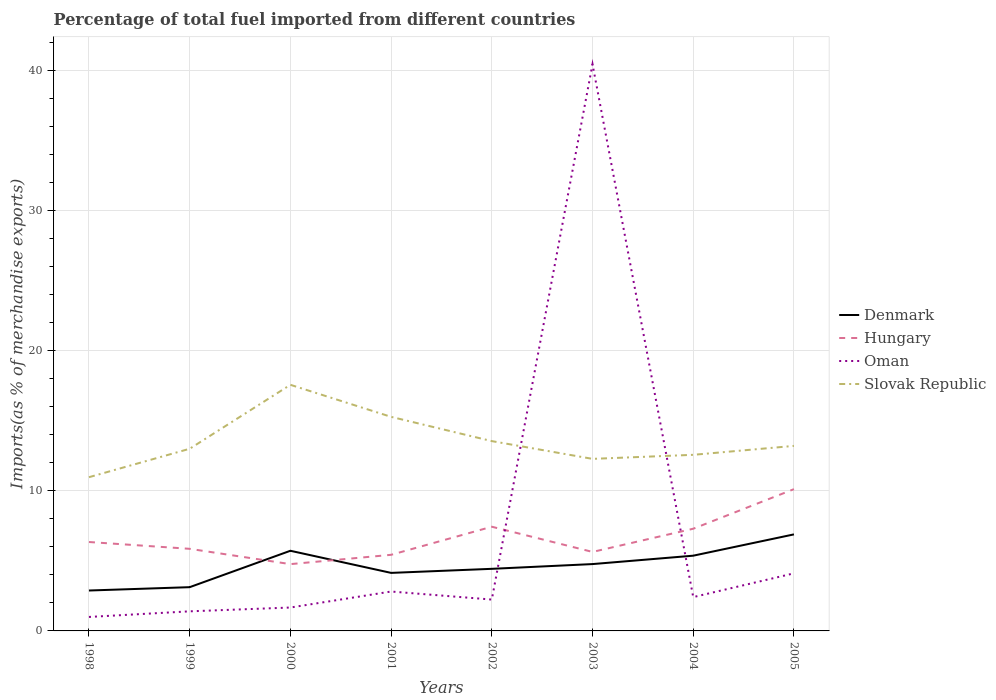Across all years, what is the maximum percentage of imports to different countries in Slovak Republic?
Provide a short and direct response. 10.98. In which year was the percentage of imports to different countries in Oman maximum?
Keep it short and to the point. 1998. What is the total percentage of imports to different countries in Slovak Republic in the graph?
Your response must be concise. 0.43. What is the difference between the highest and the second highest percentage of imports to different countries in Denmark?
Your answer should be very brief. 4.01. What is the difference between the highest and the lowest percentage of imports to different countries in Oman?
Provide a succinct answer. 1. What is the difference between two consecutive major ticks on the Y-axis?
Provide a succinct answer. 10. Does the graph contain any zero values?
Provide a short and direct response. No. Does the graph contain grids?
Provide a succinct answer. Yes. How are the legend labels stacked?
Offer a very short reply. Vertical. What is the title of the graph?
Offer a very short reply. Percentage of total fuel imported from different countries. Does "Montenegro" appear as one of the legend labels in the graph?
Keep it short and to the point. No. What is the label or title of the X-axis?
Your answer should be compact. Years. What is the label or title of the Y-axis?
Offer a very short reply. Imports(as % of merchandise exports). What is the Imports(as % of merchandise exports) of Denmark in 1998?
Make the answer very short. 2.89. What is the Imports(as % of merchandise exports) in Hungary in 1998?
Keep it short and to the point. 6.35. What is the Imports(as % of merchandise exports) of Oman in 1998?
Keep it short and to the point. 1. What is the Imports(as % of merchandise exports) in Slovak Republic in 1998?
Offer a terse response. 10.98. What is the Imports(as % of merchandise exports) of Denmark in 1999?
Offer a very short reply. 3.12. What is the Imports(as % of merchandise exports) of Hungary in 1999?
Make the answer very short. 5.86. What is the Imports(as % of merchandise exports) in Oman in 1999?
Keep it short and to the point. 1.4. What is the Imports(as % of merchandise exports) of Slovak Republic in 1999?
Offer a terse response. 13.01. What is the Imports(as % of merchandise exports) of Denmark in 2000?
Keep it short and to the point. 5.73. What is the Imports(as % of merchandise exports) of Hungary in 2000?
Your answer should be very brief. 4.77. What is the Imports(as % of merchandise exports) of Oman in 2000?
Ensure brevity in your answer.  1.67. What is the Imports(as % of merchandise exports) in Slovak Republic in 2000?
Keep it short and to the point. 17.58. What is the Imports(as % of merchandise exports) in Denmark in 2001?
Offer a terse response. 4.15. What is the Imports(as % of merchandise exports) in Hungary in 2001?
Offer a terse response. 5.44. What is the Imports(as % of merchandise exports) of Oman in 2001?
Your answer should be compact. 2.81. What is the Imports(as % of merchandise exports) of Slovak Republic in 2001?
Your answer should be very brief. 15.29. What is the Imports(as % of merchandise exports) of Denmark in 2002?
Your response must be concise. 4.44. What is the Imports(as % of merchandise exports) of Hungary in 2002?
Offer a very short reply. 7.44. What is the Imports(as % of merchandise exports) in Oman in 2002?
Your response must be concise. 2.24. What is the Imports(as % of merchandise exports) of Slovak Republic in 2002?
Provide a short and direct response. 13.56. What is the Imports(as % of merchandise exports) of Denmark in 2003?
Offer a terse response. 4.77. What is the Imports(as % of merchandise exports) in Hungary in 2003?
Your answer should be compact. 5.64. What is the Imports(as % of merchandise exports) in Oman in 2003?
Provide a succinct answer. 40.48. What is the Imports(as % of merchandise exports) in Slovak Republic in 2003?
Your response must be concise. 12.29. What is the Imports(as % of merchandise exports) in Denmark in 2004?
Make the answer very short. 5.37. What is the Imports(as % of merchandise exports) of Hungary in 2004?
Offer a terse response. 7.3. What is the Imports(as % of merchandise exports) in Oman in 2004?
Keep it short and to the point. 2.42. What is the Imports(as % of merchandise exports) in Slovak Republic in 2004?
Keep it short and to the point. 12.58. What is the Imports(as % of merchandise exports) in Denmark in 2005?
Offer a very short reply. 6.9. What is the Imports(as % of merchandise exports) of Hungary in 2005?
Provide a succinct answer. 10.13. What is the Imports(as % of merchandise exports) in Oman in 2005?
Your response must be concise. 4.11. What is the Imports(as % of merchandise exports) of Slovak Republic in 2005?
Your answer should be compact. 13.22. Across all years, what is the maximum Imports(as % of merchandise exports) in Denmark?
Ensure brevity in your answer.  6.9. Across all years, what is the maximum Imports(as % of merchandise exports) of Hungary?
Your answer should be very brief. 10.13. Across all years, what is the maximum Imports(as % of merchandise exports) of Oman?
Provide a succinct answer. 40.48. Across all years, what is the maximum Imports(as % of merchandise exports) of Slovak Republic?
Give a very brief answer. 17.58. Across all years, what is the minimum Imports(as % of merchandise exports) in Denmark?
Provide a succinct answer. 2.89. Across all years, what is the minimum Imports(as % of merchandise exports) in Hungary?
Ensure brevity in your answer.  4.77. Across all years, what is the minimum Imports(as % of merchandise exports) in Oman?
Keep it short and to the point. 1. Across all years, what is the minimum Imports(as % of merchandise exports) in Slovak Republic?
Give a very brief answer. 10.98. What is the total Imports(as % of merchandise exports) of Denmark in the graph?
Make the answer very short. 37.36. What is the total Imports(as % of merchandise exports) in Hungary in the graph?
Provide a short and direct response. 52.93. What is the total Imports(as % of merchandise exports) in Oman in the graph?
Your response must be concise. 56.13. What is the total Imports(as % of merchandise exports) in Slovak Republic in the graph?
Provide a succinct answer. 108.5. What is the difference between the Imports(as % of merchandise exports) of Denmark in 1998 and that in 1999?
Offer a very short reply. -0.24. What is the difference between the Imports(as % of merchandise exports) of Hungary in 1998 and that in 1999?
Give a very brief answer. 0.49. What is the difference between the Imports(as % of merchandise exports) of Oman in 1998 and that in 1999?
Your answer should be compact. -0.4. What is the difference between the Imports(as % of merchandise exports) of Slovak Republic in 1998 and that in 1999?
Make the answer very short. -2.03. What is the difference between the Imports(as % of merchandise exports) of Denmark in 1998 and that in 2000?
Your response must be concise. -2.84. What is the difference between the Imports(as % of merchandise exports) of Hungary in 1998 and that in 2000?
Ensure brevity in your answer.  1.58. What is the difference between the Imports(as % of merchandise exports) in Oman in 1998 and that in 2000?
Offer a very short reply. -0.67. What is the difference between the Imports(as % of merchandise exports) in Slovak Republic in 1998 and that in 2000?
Ensure brevity in your answer.  -6.6. What is the difference between the Imports(as % of merchandise exports) in Denmark in 1998 and that in 2001?
Ensure brevity in your answer.  -1.26. What is the difference between the Imports(as % of merchandise exports) in Hungary in 1998 and that in 2001?
Provide a short and direct response. 0.91. What is the difference between the Imports(as % of merchandise exports) in Oman in 1998 and that in 2001?
Make the answer very short. -1.82. What is the difference between the Imports(as % of merchandise exports) of Slovak Republic in 1998 and that in 2001?
Provide a succinct answer. -4.31. What is the difference between the Imports(as % of merchandise exports) of Denmark in 1998 and that in 2002?
Give a very brief answer. -1.55. What is the difference between the Imports(as % of merchandise exports) in Hungary in 1998 and that in 2002?
Ensure brevity in your answer.  -1.09. What is the difference between the Imports(as % of merchandise exports) of Oman in 1998 and that in 2002?
Your response must be concise. -1.24. What is the difference between the Imports(as % of merchandise exports) in Slovak Republic in 1998 and that in 2002?
Provide a short and direct response. -2.58. What is the difference between the Imports(as % of merchandise exports) of Denmark in 1998 and that in 2003?
Your answer should be compact. -1.89. What is the difference between the Imports(as % of merchandise exports) in Hungary in 1998 and that in 2003?
Give a very brief answer. 0.71. What is the difference between the Imports(as % of merchandise exports) of Oman in 1998 and that in 2003?
Ensure brevity in your answer.  -39.48. What is the difference between the Imports(as % of merchandise exports) of Slovak Republic in 1998 and that in 2003?
Your answer should be compact. -1.31. What is the difference between the Imports(as % of merchandise exports) of Denmark in 1998 and that in 2004?
Offer a very short reply. -2.49. What is the difference between the Imports(as % of merchandise exports) of Hungary in 1998 and that in 2004?
Make the answer very short. -0.95. What is the difference between the Imports(as % of merchandise exports) in Oman in 1998 and that in 2004?
Give a very brief answer. -1.42. What is the difference between the Imports(as % of merchandise exports) in Slovak Republic in 1998 and that in 2004?
Your answer should be compact. -1.6. What is the difference between the Imports(as % of merchandise exports) in Denmark in 1998 and that in 2005?
Provide a short and direct response. -4.01. What is the difference between the Imports(as % of merchandise exports) of Hungary in 1998 and that in 2005?
Your answer should be compact. -3.78. What is the difference between the Imports(as % of merchandise exports) of Oman in 1998 and that in 2005?
Give a very brief answer. -3.12. What is the difference between the Imports(as % of merchandise exports) in Slovak Republic in 1998 and that in 2005?
Provide a succinct answer. -2.24. What is the difference between the Imports(as % of merchandise exports) in Denmark in 1999 and that in 2000?
Provide a succinct answer. -2.6. What is the difference between the Imports(as % of merchandise exports) in Hungary in 1999 and that in 2000?
Give a very brief answer. 1.09. What is the difference between the Imports(as % of merchandise exports) of Oman in 1999 and that in 2000?
Your response must be concise. -0.27. What is the difference between the Imports(as % of merchandise exports) in Slovak Republic in 1999 and that in 2000?
Provide a short and direct response. -4.57. What is the difference between the Imports(as % of merchandise exports) in Denmark in 1999 and that in 2001?
Give a very brief answer. -1.02. What is the difference between the Imports(as % of merchandise exports) in Hungary in 1999 and that in 2001?
Provide a succinct answer. 0.43. What is the difference between the Imports(as % of merchandise exports) of Oman in 1999 and that in 2001?
Provide a succinct answer. -1.41. What is the difference between the Imports(as % of merchandise exports) in Slovak Republic in 1999 and that in 2001?
Provide a short and direct response. -2.28. What is the difference between the Imports(as % of merchandise exports) in Denmark in 1999 and that in 2002?
Give a very brief answer. -1.31. What is the difference between the Imports(as % of merchandise exports) of Hungary in 1999 and that in 2002?
Your answer should be very brief. -1.58. What is the difference between the Imports(as % of merchandise exports) in Oman in 1999 and that in 2002?
Your response must be concise. -0.84. What is the difference between the Imports(as % of merchandise exports) in Slovak Republic in 1999 and that in 2002?
Give a very brief answer. -0.55. What is the difference between the Imports(as % of merchandise exports) in Denmark in 1999 and that in 2003?
Provide a short and direct response. -1.65. What is the difference between the Imports(as % of merchandise exports) in Hungary in 1999 and that in 2003?
Your answer should be compact. 0.22. What is the difference between the Imports(as % of merchandise exports) of Oman in 1999 and that in 2003?
Keep it short and to the point. -39.08. What is the difference between the Imports(as % of merchandise exports) in Slovak Republic in 1999 and that in 2003?
Provide a succinct answer. 0.72. What is the difference between the Imports(as % of merchandise exports) of Denmark in 1999 and that in 2004?
Your response must be concise. -2.25. What is the difference between the Imports(as % of merchandise exports) of Hungary in 1999 and that in 2004?
Provide a succinct answer. -1.44. What is the difference between the Imports(as % of merchandise exports) of Oman in 1999 and that in 2004?
Ensure brevity in your answer.  -1.02. What is the difference between the Imports(as % of merchandise exports) of Slovak Republic in 1999 and that in 2004?
Offer a very short reply. 0.43. What is the difference between the Imports(as % of merchandise exports) of Denmark in 1999 and that in 2005?
Your response must be concise. -3.77. What is the difference between the Imports(as % of merchandise exports) in Hungary in 1999 and that in 2005?
Offer a very short reply. -4.26. What is the difference between the Imports(as % of merchandise exports) in Oman in 1999 and that in 2005?
Offer a terse response. -2.71. What is the difference between the Imports(as % of merchandise exports) in Slovak Republic in 1999 and that in 2005?
Keep it short and to the point. -0.2. What is the difference between the Imports(as % of merchandise exports) in Denmark in 2000 and that in 2001?
Your answer should be very brief. 1.58. What is the difference between the Imports(as % of merchandise exports) in Hungary in 2000 and that in 2001?
Provide a succinct answer. -0.67. What is the difference between the Imports(as % of merchandise exports) of Oman in 2000 and that in 2001?
Your answer should be very brief. -1.14. What is the difference between the Imports(as % of merchandise exports) of Slovak Republic in 2000 and that in 2001?
Your answer should be very brief. 2.29. What is the difference between the Imports(as % of merchandise exports) in Denmark in 2000 and that in 2002?
Your response must be concise. 1.29. What is the difference between the Imports(as % of merchandise exports) in Hungary in 2000 and that in 2002?
Offer a terse response. -2.67. What is the difference between the Imports(as % of merchandise exports) in Oman in 2000 and that in 2002?
Your answer should be very brief. -0.57. What is the difference between the Imports(as % of merchandise exports) of Slovak Republic in 2000 and that in 2002?
Your answer should be compact. 4.02. What is the difference between the Imports(as % of merchandise exports) in Denmark in 2000 and that in 2003?
Make the answer very short. 0.95. What is the difference between the Imports(as % of merchandise exports) of Hungary in 2000 and that in 2003?
Provide a succinct answer. -0.87. What is the difference between the Imports(as % of merchandise exports) in Oman in 2000 and that in 2003?
Your answer should be very brief. -38.81. What is the difference between the Imports(as % of merchandise exports) in Slovak Republic in 2000 and that in 2003?
Provide a succinct answer. 5.29. What is the difference between the Imports(as % of merchandise exports) of Denmark in 2000 and that in 2004?
Your response must be concise. 0.35. What is the difference between the Imports(as % of merchandise exports) in Hungary in 2000 and that in 2004?
Make the answer very short. -2.53. What is the difference between the Imports(as % of merchandise exports) of Oman in 2000 and that in 2004?
Keep it short and to the point. -0.74. What is the difference between the Imports(as % of merchandise exports) in Slovak Republic in 2000 and that in 2004?
Your answer should be very brief. 5. What is the difference between the Imports(as % of merchandise exports) in Denmark in 2000 and that in 2005?
Give a very brief answer. -1.17. What is the difference between the Imports(as % of merchandise exports) in Hungary in 2000 and that in 2005?
Your response must be concise. -5.36. What is the difference between the Imports(as % of merchandise exports) in Oman in 2000 and that in 2005?
Provide a succinct answer. -2.44. What is the difference between the Imports(as % of merchandise exports) of Slovak Republic in 2000 and that in 2005?
Your answer should be very brief. 4.36. What is the difference between the Imports(as % of merchandise exports) of Denmark in 2001 and that in 2002?
Provide a short and direct response. -0.29. What is the difference between the Imports(as % of merchandise exports) in Hungary in 2001 and that in 2002?
Your answer should be compact. -2.01. What is the difference between the Imports(as % of merchandise exports) of Oman in 2001 and that in 2002?
Ensure brevity in your answer.  0.57. What is the difference between the Imports(as % of merchandise exports) in Slovak Republic in 2001 and that in 2002?
Provide a succinct answer. 1.73. What is the difference between the Imports(as % of merchandise exports) in Denmark in 2001 and that in 2003?
Provide a succinct answer. -0.63. What is the difference between the Imports(as % of merchandise exports) of Hungary in 2001 and that in 2003?
Give a very brief answer. -0.21. What is the difference between the Imports(as % of merchandise exports) of Oman in 2001 and that in 2003?
Give a very brief answer. -37.66. What is the difference between the Imports(as % of merchandise exports) of Slovak Republic in 2001 and that in 2003?
Make the answer very short. 3. What is the difference between the Imports(as % of merchandise exports) in Denmark in 2001 and that in 2004?
Offer a terse response. -1.23. What is the difference between the Imports(as % of merchandise exports) in Hungary in 2001 and that in 2004?
Offer a very short reply. -1.86. What is the difference between the Imports(as % of merchandise exports) in Oman in 2001 and that in 2004?
Your answer should be compact. 0.4. What is the difference between the Imports(as % of merchandise exports) of Slovak Republic in 2001 and that in 2004?
Ensure brevity in your answer.  2.71. What is the difference between the Imports(as % of merchandise exports) in Denmark in 2001 and that in 2005?
Provide a short and direct response. -2.75. What is the difference between the Imports(as % of merchandise exports) in Hungary in 2001 and that in 2005?
Make the answer very short. -4.69. What is the difference between the Imports(as % of merchandise exports) of Oman in 2001 and that in 2005?
Your answer should be compact. -1.3. What is the difference between the Imports(as % of merchandise exports) in Slovak Republic in 2001 and that in 2005?
Provide a succinct answer. 2.07. What is the difference between the Imports(as % of merchandise exports) in Denmark in 2002 and that in 2003?
Offer a very short reply. -0.34. What is the difference between the Imports(as % of merchandise exports) in Hungary in 2002 and that in 2003?
Provide a succinct answer. 1.8. What is the difference between the Imports(as % of merchandise exports) in Oman in 2002 and that in 2003?
Your response must be concise. -38.24. What is the difference between the Imports(as % of merchandise exports) of Slovak Republic in 2002 and that in 2003?
Your answer should be very brief. 1.27. What is the difference between the Imports(as % of merchandise exports) in Denmark in 2002 and that in 2004?
Your response must be concise. -0.94. What is the difference between the Imports(as % of merchandise exports) of Hungary in 2002 and that in 2004?
Provide a succinct answer. 0.14. What is the difference between the Imports(as % of merchandise exports) of Oman in 2002 and that in 2004?
Give a very brief answer. -0.18. What is the difference between the Imports(as % of merchandise exports) of Slovak Republic in 2002 and that in 2004?
Your response must be concise. 0.98. What is the difference between the Imports(as % of merchandise exports) in Denmark in 2002 and that in 2005?
Offer a very short reply. -2.46. What is the difference between the Imports(as % of merchandise exports) in Hungary in 2002 and that in 2005?
Make the answer very short. -2.68. What is the difference between the Imports(as % of merchandise exports) in Oman in 2002 and that in 2005?
Give a very brief answer. -1.87. What is the difference between the Imports(as % of merchandise exports) in Slovak Republic in 2002 and that in 2005?
Ensure brevity in your answer.  0.34. What is the difference between the Imports(as % of merchandise exports) in Denmark in 2003 and that in 2004?
Offer a very short reply. -0.6. What is the difference between the Imports(as % of merchandise exports) in Hungary in 2003 and that in 2004?
Provide a short and direct response. -1.66. What is the difference between the Imports(as % of merchandise exports) in Oman in 2003 and that in 2004?
Give a very brief answer. 38.06. What is the difference between the Imports(as % of merchandise exports) of Slovak Republic in 2003 and that in 2004?
Ensure brevity in your answer.  -0.29. What is the difference between the Imports(as % of merchandise exports) in Denmark in 2003 and that in 2005?
Your response must be concise. -2.12. What is the difference between the Imports(as % of merchandise exports) of Hungary in 2003 and that in 2005?
Your response must be concise. -4.48. What is the difference between the Imports(as % of merchandise exports) of Oman in 2003 and that in 2005?
Offer a terse response. 36.37. What is the difference between the Imports(as % of merchandise exports) in Slovak Republic in 2003 and that in 2005?
Give a very brief answer. -0.93. What is the difference between the Imports(as % of merchandise exports) in Denmark in 2004 and that in 2005?
Your answer should be compact. -1.52. What is the difference between the Imports(as % of merchandise exports) of Hungary in 2004 and that in 2005?
Give a very brief answer. -2.83. What is the difference between the Imports(as % of merchandise exports) of Oman in 2004 and that in 2005?
Give a very brief answer. -1.7. What is the difference between the Imports(as % of merchandise exports) in Slovak Republic in 2004 and that in 2005?
Make the answer very short. -0.64. What is the difference between the Imports(as % of merchandise exports) in Denmark in 1998 and the Imports(as % of merchandise exports) in Hungary in 1999?
Keep it short and to the point. -2.98. What is the difference between the Imports(as % of merchandise exports) of Denmark in 1998 and the Imports(as % of merchandise exports) of Oman in 1999?
Your response must be concise. 1.49. What is the difference between the Imports(as % of merchandise exports) in Denmark in 1998 and the Imports(as % of merchandise exports) in Slovak Republic in 1999?
Your response must be concise. -10.13. What is the difference between the Imports(as % of merchandise exports) of Hungary in 1998 and the Imports(as % of merchandise exports) of Oman in 1999?
Provide a short and direct response. 4.95. What is the difference between the Imports(as % of merchandise exports) in Hungary in 1998 and the Imports(as % of merchandise exports) in Slovak Republic in 1999?
Your answer should be compact. -6.66. What is the difference between the Imports(as % of merchandise exports) in Oman in 1998 and the Imports(as % of merchandise exports) in Slovak Republic in 1999?
Ensure brevity in your answer.  -12.01. What is the difference between the Imports(as % of merchandise exports) of Denmark in 1998 and the Imports(as % of merchandise exports) of Hungary in 2000?
Your answer should be compact. -1.88. What is the difference between the Imports(as % of merchandise exports) of Denmark in 1998 and the Imports(as % of merchandise exports) of Oman in 2000?
Your answer should be compact. 1.21. What is the difference between the Imports(as % of merchandise exports) in Denmark in 1998 and the Imports(as % of merchandise exports) in Slovak Republic in 2000?
Your response must be concise. -14.69. What is the difference between the Imports(as % of merchandise exports) in Hungary in 1998 and the Imports(as % of merchandise exports) in Oman in 2000?
Your response must be concise. 4.68. What is the difference between the Imports(as % of merchandise exports) in Hungary in 1998 and the Imports(as % of merchandise exports) in Slovak Republic in 2000?
Ensure brevity in your answer.  -11.23. What is the difference between the Imports(as % of merchandise exports) in Oman in 1998 and the Imports(as % of merchandise exports) in Slovak Republic in 2000?
Your response must be concise. -16.58. What is the difference between the Imports(as % of merchandise exports) in Denmark in 1998 and the Imports(as % of merchandise exports) in Hungary in 2001?
Provide a succinct answer. -2.55. What is the difference between the Imports(as % of merchandise exports) in Denmark in 1998 and the Imports(as % of merchandise exports) in Oman in 2001?
Make the answer very short. 0.07. What is the difference between the Imports(as % of merchandise exports) of Denmark in 1998 and the Imports(as % of merchandise exports) of Slovak Republic in 2001?
Your answer should be compact. -12.4. What is the difference between the Imports(as % of merchandise exports) of Hungary in 1998 and the Imports(as % of merchandise exports) of Oman in 2001?
Ensure brevity in your answer.  3.54. What is the difference between the Imports(as % of merchandise exports) in Hungary in 1998 and the Imports(as % of merchandise exports) in Slovak Republic in 2001?
Offer a very short reply. -8.94. What is the difference between the Imports(as % of merchandise exports) of Oman in 1998 and the Imports(as % of merchandise exports) of Slovak Republic in 2001?
Provide a short and direct response. -14.29. What is the difference between the Imports(as % of merchandise exports) in Denmark in 1998 and the Imports(as % of merchandise exports) in Hungary in 2002?
Your answer should be very brief. -4.56. What is the difference between the Imports(as % of merchandise exports) in Denmark in 1998 and the Imports(as % of merchandise exports) in Oman in 2002?
Give a very brief answer. 0.65. What is the difference between the Imports(as % of merchandise exports) in Denmark in 1998 and the Imports(as % of merchandise exports) in Slovak Republic in 2002?
Offer a very short reply. -10.67. What is the difference between the Imports(as % of merchandise exports) of Hungary in 1998 and the Imports(as % of merchandise exports) of Oman in 2002?
Keep it short and to the point. 4.11. What is the difference between the Imports(as % of merchandise exports) in Hungary in 1998 and the Imports(as % of merchandise exports) in Slovak Republic in 2002?
Offer a very short reply. -7.21. What is the difference between the Imports(as % of merchandise exports) of Oman in 1998 and the Imports(as % of merchandise exports) of Slovak Republic in 2002?
Keep it short and to the point. -12.56. What is the difference between the Imports(as % of merchandise exports) of Denmark in 1998 and the Imports(as % of merchandise exports) of Hungary in 2003?
Provide a succinct answer. -2.76. What is the difference between the Imports(as % of merchandise exports) of Denmark in 1998 and the Imports(as % of merchandise exports) of Oman in 2003?
Provide a succinct answer. -37.59. What is the difference between the Imports(as % of merchandise exports) in Denmark in 1998 and the Imports(as % of merchandise exports) in Slovak Republic in 2003?
Keep it short and to the point. -9.4. What is the difference between the Imports(as % of merchandise exports) of Hungary in 1998 and the Imports(as % of merchandise exports) of Oman in 2003?
Your answer should be compact. -34.13. What is the difference between the Imports(as % of merchandise exports) of Hungary in 1998 and the Imports(as % of merchandise exports) of Slovak Republic in 2003?
Offer a terse response. -5.94. What is the difference between the Imports(as % of merchandise exports) of Oman in 1998 and the Imports(as % of merchandise exports) of Slovak Republic in 2003?
Offer a very short reply. -11.29. What is the difference between the Imports(as % of merchandise exports) of Denmark in 1998 and the Imports(as % of merchandise exports) of Hungary in 2004?
Provide a short and direct response. -4.41. What is the difference between the Imports(as % of merchandise exports) of Denmark in 1998 and the Imports(as % of merchandise exports) of Oman in 2004?
Your response must be concise. 0.47. What is the difference between the Imports(as % of merchandise exports) of Denmark in 1998 and the Imports(as % of merchandise exports) of Slovak Republic in 2004?
Keep it short and to the point. -9.69. What is the difference between the Imports(as % of merchandise exports) of Hungary in 1998 and the Imports(as % of merchandise exports) of Oman in 2004?
Your response must be concise. 3.94. What is the difference between the Imports(as % of merchandise exports) of Hungary in 1998 and the Imports(as % of merchandise exports) of Slovak Republic in 2004?
Your answer should be very brief. -6.23. What is the difference between the Imports(as % of merchandise exports) of Oman in 1998 and the Imports(as % of merchandise exports) of Slovak Republic in 2004?
Give a very brief answer. -11.58. What is the difference between the Imports(as % of merchandise exports) in Denmark in 1998 and the Imports(as % of merchandise exports) in Hungary in 2005?
Offer a terse response. -7.24. What is the difference between the Imports(as % of merchandise exports) of Denmark in 1998 and the Imports(as % of merchandise exports) of Oman in 2005?
Your response must be concise. -1.23. What is the difference between the Imports(as % of merchandise exports) in Denmark in 1998 and the Imports(as % of merchandise exports) in Slovak Republic in 2005?
Provide a short and direct response. -10.33. What is the difference between the Imports(as % of merchandise exports) in Hungary in 1998 and the Imports(as % of merchandise exports) in Oman in 2005?
Offer a terse response. 2.24. What is the difference between the Imports(as % of merchandise exports) in Hungary in 1998 and the Imports(as % of merchandise exports) in Slovak Republic in 2005?
Your answer should be compact. -6.87. What is the difference between the Imports(as % of merchandise exports) of Oman in 1998 and the Imports(as % of merchandise exports) of Slovak Republic in 2005?
Provide a succinct answer. -12.22. What is the difference between the Imports(as % of merchandise exports) in Denmark in 1999 and the Imports(as % of merchandise exports) in Hungary in 2000?
Provide a short and direct response. -1.65. What is the difference between the Imports(as % of merchandise exports) of Denmark in 1999 and the Imports(as % of merchandise exports) of Oman in 2000?
Make the answer very short. 1.45. What is the difference between the Imports(as % of merchandise exports) in Denmark in 1999 and the Imports(as % of merchandise exports) in Slovak Republic in 2000?
Ensure brevity in your answer.  -14.45. What is the difference between the Imports(as % of merchandise exports) in Hungary in 1999 and the Imports(as % of merchandise exports) in Oman in 2000?
Your answer should be compact. 4.19. What is the difference between the Imports(as % of merchandise exports) in Hungary in 1999 and the Imports(as % of merchandise exports) in Slovak Republic in 2000?
Your answer should be very brief. -11.72. What is the difference between the Imports(as % of merchandise exports) in Oman in 1999 and the Imports(as % of merchandise exports) in Slovak Republic in 2000?
Your response must be concise. -16.18. What is the difference between the Imports(as % of merchandise exports) of Denmark in 1999 and the Imports(as % of merchandise exports) of Hungary in 2001?
Your answer should be compact. -2.31. What is the difference between the Imports(as % of merchandise exports) of Denmark in 1999 and the Imports(as % of merchandise exports) of Oman in 2001?
Your answer should be very brief. 0.31. What is the difference between the Imports(as % of merchandise exports) of Denmark in 1999 and the Imports(as % of merchandise exports) of Slovak Republic in 2001?
Give a very brief answer. -12.17. What is the difference between the Imports(as % of merchandise exports) in Hungary in 1999 and the Imports(as % of merchandise exports) in Oman in 2001?
Offer a terse response. 3.05. What is the difference between the Imports(as % of merchandise exports) of Hungary in 1999 and the Imports(as % of merchandise exports) of Slovak Republic in 2001?
Keep it short and to the point. -9.43. What is the difference between the Imports(as % of merchandise exports) in Oman in 1999 and the Imports(as % of merchandise exports) in Slovak Republic in 2001?
Ensure brevity in your answer.  -13.89. What is the difference between the Imports(as % of merchandise exports) of Denmark in 1999 and the Imports(as % of merchandise exports) of Hungary in 2002?
Ensure brevity in your answer.  -4.32. What is the difference between the Imports(as % of merchandise exports) in Denmark in 1999 and the Imports(as % of merchandise exports) in Oman in 2002?
Keep it short and to the point. 0.89. What is the difference between the Imports(as % of merchandise exports) in Denmark in 1999 and the Imports(as % of merchandise exports) in Slovak Republic in 2002?
Your answer should be compact. -10.43. What is the difference between the Imports(as % of merchandise exports) of Hungary in 1999 and the Imports(as % of merchandise exports) of Oman in 2002?
Your response must be concise. 3.62. What is the difference between the Imports(as % of merchandise exports) of Hungary in 1999 and the Imports(as % of merchandise exports) of Slovak Republic in 2002?
Keep it short and to the point. -7.69. What is the difference between the Imports(as % of merchandise exports) in Oman in 1999 and the Imports(as % of merchandise exports) in Slovak Republic in 2002?
Keep it short and to the point. -12.16. What is the difference between the Imports(as % of merchandise exports) in Denmark in 1999 and the Imports(as % of merchandise exports) in Hungary in 2003?
Give a very brief answer. -2.52. What is the difference between the Imports(as % of merchandise exports) of Denmark in 1999 and the Imports(as % of merchandise exports) of Oman in 2003?
Ensure brevity in your answer.  -37.35. What is the difference between the Imports(as % of merchandise exports) in Denmark in 1999 and the Imports(as % of merchandise exports) in Slovak Republic in 2003?
Your answer should be very brief. -9.16. What is the difference between the Imports(as % of merchandise exports) of Hungary in 1999 and the Imports(as % of merchandise exports) of Oman in 2003?
Offer a terse response. -34.61. What is the difference between the Imports(as % of merchandise exports) of Hungary in 1999 and the Imports(as % of merchandise exports) of Slovak Republic in 2003?
Give a very brief answer. -6.42. What is the difference between the Imports(as % of merchandise exports) of Oman in 1999 and the Imports(as % of merchandise exports) of Slovak Republic in 2003?
Offer a terse response. -10.89. What is the difference between the Imports(as % of merchandise exports) of Denmark in 1999 and the Imports(as % of merchandise exports) of Hungary in 2004?
Offer a very short reply. -4.17. What is the difference between the Imports(as % of merchandise exports) in Denmark in 1999 and the Imports(as % of merchandise exports) in Oman in 2004?
Your answer should be very brief. 0.71. What is the difference between the Imports(as % of merchandise exports) of Denmark in 1999 and the Imports(as % of merchandise exports) of Slovak Republic in 2004?
Your answer should be very brief. -9.45. What is the difference between the Imports(as % of merchandise exports) of Hungary in 1999 and the Imports(as % of merchandise exports) of Oman in 2004?
Give a very brief answer. 3.45. What is the difference between the Imports(as % of merchandise exports) in Hungary in 1999 and the Imports(as % of merchandise exports) in Slovak Republic in 2004?
Keep it short and to the point. -6.71. What is the difference between the Imports(as % of merchandise exports) of Oman in 1999 and the Imports(as % of merchandise exports) of Slovak Republic in 2004?
Give a very brief answer. -11.18. What is the difference between the Imports(as % of merchandise exports) of Denmark in 1999 and the Imports(as % of merchandise exports) of Hungary in 2005?
Offer a very short reply. -7. What is the difference between the Imports(as % of merchandise exports) of Denmark in 1999 and the Imports(as % of merchandise exports) of Oman in 2005?
Offer a very short reply. -0.99. What is the difference between the Imports(as % of merchandise exports) of Denmark in 1999 and the Imports(as % of merchandise exports) of Slovak Republic in 2005?
Ensure brevity in your answer.  -10.09. What is the difference between the Imports(as % of merchandise exports) in Hungary in 1999 and the Imports(as % of merchandise exports) in Oman in 2005?
Your response must be concise. 1.75. What is the difference between the Imports(as % of merchandise exports) of Hungary in 1999 and the Imports(as % of merchandise exports) of Slovak Republic in 2005?
Offer a very short reply. -7.35. What is the difference between the Imports(as % of merchandise exports) in Oman in 1999 and the Imports(as % of merchandise exports) in Slovak Republic in 2005?
Keep it short and to the point. -11.82. What is the difference between the Imports(as % of merchandise exports) in Denmark in 2000 and the Imports(as % of merchandise exports) in Hungary in 2001?
Provide a succinct answer. 0.29. What is the difference between the Imports(as % of merchandise exports) of Denmark in 2000 and the Imports(as % of merchandise exports) of Oman in 2001?
Offer a very short reply. 2.91. What is the difference between the Imports(as % of merchandise exports) of Denmark in 2000 and the Imports(as % of merchandise exports) of Slovak Republic in 2001?
Your answer should be compact. -9.57. What is the difference between the Imports(as % of merchandise exports) of Hungary in 2000 and the Imports(as % of merchandise exports) of Oman in 2001?
Provide a short and direct response. 1.96. What is the difference between the Imports(as % of merchandise exports) in Hungary in 2000 and the Imports(as % of merchandise exports) in Slovak Republic in 2001?
Offer a very short reply. -10.52. What is the difference between the Imports(as % of merchandise exports) in Oman in 2000 and the Imports(as % of merchandise exports) in Slovak Republic in 2001?
Your answer should be very brief. -13.62. What is the difference between the Imports(as % of merchandise exports) in Denmark in 2000 and the Imports(as % of merchandise exports) in Hungary in 2002?
Ensure brevity in your answer.  -1.72. What is the difference between the Imports(as % of merchandise exports) in Denmark in 2000 and the Imports(as % of merchandise exports) in Oman in 2002?
Ensure brevity in your answer.  3.49. What is the difference between the Imports(as % of merchandise exports) of Denmark in 2000 and the Imports(as % of merchandise exports) of Slovak Republic in 2002?
Make the answer very short. -7.83. What is the difference between the Imports(as % of merchandise exports) of Hungary in 2000 and the Imports(as % of merchandise exports) of Oman in 2002?
Keep it short and to the point. 2.53. What is the difference between the Imports(as % of merchandise exports) of Hungary in 2000 and the Imports(as % of merchandise exports) of Slovak Republic in 2002?
Your answer should be compact. -8.79. What is the difference between the Imports(as % of merchandise exports) in Oman in 2000 and the Imports(as % of merchandise exports) in Slovak Republic in 2002?
Ensure brevity in your answer.  -11.89. What is the difference between the Imports(as % of merchandise exports) of Denmark in 2000 and the Imports(as % of merchandise exports) of Hungary in 2003?
Offer a terse response. 0.08. What is the difference between the Imports(as % of merchandise exports) of Denmark in 2000 and the Imports(as % of merchandise exports) of Oman in 2003?
Keep it short and to the point. -34.75. What is the difference between the Imports(as % of merchandise exports) in Denmark in 2000 and the Imports(as % of merchandise exports) in Slovak Republic in 2003?
Your answer should be very brief. -6.56. What is the difference between the Imports(as % of merchandise exports) in Hungary in 2000 and the Imports(as % of merchandise exports) in Oman in 2003?
Your response must be concise. -35.71. What is the difference between the Imports(as % of merchandise exports) of Hungary in 2000 and the Imports(as % of merchandise exports) of Slovak Republic in 2003?
Your answer should be compact. -7.52. What is the difference between the Imports(as % of merchandise exports) in Oman in 2000 and the Imports(as % of merchandise exports) in Slovak Republic in 2003?
Your response must be concise. -10.62. What is the difference between the Imports(as % of merchandise exports) in Denmark in 2000 and the Imports(as % of merchandise exports) in Hungary in 2004?
Your answer should be very brief. -1.57. What is the difference between the Imports(as % of merchandise exports) in Denmark in 2000 and the Imports(as % of merchandise exports) in Oman in 2004?
Provide a succinct answer. 3.31. What is the difference between the Imports(as % of merchandise exports) of Denmark in 2000 and the Imports(as % of merchandise exports) of Slovak Republic in 2004?
Give a very brief answer. -6.85. What is the difference between the Imports(as % of merchandise exports) of Hungary in 2000 and the Imports(as % of merchandise exports) of Oman in 2004?
Ensure brevity in your answer.  2.36. What is the difference between the Imports(as % of merchandise exports) in Hungary in 2000 and the Imports(as % of merchandise exports) in Slovak Republic in 2004?
Your answer should be very brief. -7.81. What is the difference between the Imports(as % of merchandise exports) of Oman in 2000 and the Imports(as % of merchandise exports) of Slovak Republic in 2004?
Provide a short and direct response. -10.91. What is the difference between the Imports(as % of merchandise exports) of Denmark in 2000 and the Imports(as % of merchandise exports) of Hungary in 2005?
Your answer should be very brief. -4.4. What is the difference between the Imports(as % of merchandise exports) in Denmark in 2000 and the Imports(as % of merchandise exports) in Oman in 2005?
Provide a short and direct response. 1.61. What is the difference between the Imports(as % of merchandise exports) of Denmark in 2000 and the Imports(as % of merchandise exports) of Slovak Republic in 2005?
Provide a short and direct response. -7.49. What is the difference between the Imports(as % of merchandise exports) in Hungary in 2000 and the Imports(as % of merchandise exports) in Oman in 2005?
Make the answer very short. 0.66. What is the difference between the Imports(as % of merchandise exports) in Hungary in 2000 and the Imports(as % of merchandise exports) in Slovak Republic in 2005?
Your answer should be very brief. -8.45. What is the difference between the Imports(as % of merchandise exports) in Oman in 2000 and the Imports(as % of merchandise exports) in Slovak Republic in 2005?
Provide a short and direct response. -11.54. What is the difference between the Imports(as % of merchandise exports) of Denmark in 2001 and the Imports(as % of merchandise exports) of Hungary in 2002?
Your answer should be compact. -3.3. What is the difference between the Imports(as % of merchandise exports) in Denmark in 2001 and the Imports(as % of merchandise exports) in Oman in 2002?
Provide a succinct answer. 1.91. What is the difference between the Imports(as % of merchandise exports) in Denmark in 2001 and the Imports(as % of merchandise exports) in Slovak Republic in 2002?
Give a very brief answer. -9.41. What is the difference between the Imports(as % of merchandise exports) in Hungary in 2001 and the Imports(as % of merchandise exports) in Oman in 2002?
Offer a very short reply. 3.2. What is the difference between the Imports(as % of merchandise exports) in Hungary in 2001 and the Imports(as % of merchandise exports) in Slovak Republic in 2002?
Provide a succinct answer. -8.12. What is the difference between the Imports(as % of merchandise exports) in Oman in 2001 and the Imports(as % of merchandise exports) in Slovak Republic in 2002?
Provide a short and direct response. -10.74. What is the difference between the Imports(as % of merchandise exports) of Denmark in 2001 and the Imports(as % of merchandise exports) of Hungary in 2003?
Provide a succinct answer. -1.5. What is the difference between the Imports(as % of merchandise exports) in Denmark in 2001 and the Imports(as % of merchandise exports) in Oman in 2003?
Provide a succinct answer. -36.33. What is the difference between the Imports(as % of merchandise exports) in Denmark in 2001 and the Imports(as % of merchandise exports) in Slovak Republic in 2003?
Give a very brief answer. -8.14. What is the difference between the Imports(as % of merchandise exports) in Hungary in 2001 and the Imports(as % of merchandise exports) in Oman in 2003?
Keep it short and to the point. -35.04. What is the difference between the Imports(as % of merchandise exports) of Hungary in 2001 and the Imports(as % of merchandise exports) of Slovak Republic in 2003?
Offer a very short reply. -6.85. What is the difference between the Imports(as % of merchandise exports) of Oman in 2001 and the Imports(as % of merchandise exports) of Slovak Republic in 2003?
Make the answer very short. -9.47. What is the difference between the Imports(as % of merchandise exports) in Denmark in 2001 and the Imports(as % of merchandise exports) in Hungary in 2004?
Your response must be concise. -3.15. What is the difference between the Imports(as % of merchandise exports) in Denmark in 2001 and the Imports(as % of merchandise exports) in Oman in 2004?
Offer a very short reply. 1.73. What is the difference between the Imports(as % of merchandise exports) of Denmark in 2001 and the Imports(as % of merchandise exports) of Slovak Republic in 2004?
Your answer should be compact. -8.43. What is the difference between the Imports(as % of merchandise exports) of Hungary in 2001 and the Imports(as % of merchandise exports) of Oman in 2004?
Provide a succinct answer. 3.02. What is the difference between the Imports(as % of merchandise exports) of Hungary in 2001 and the Imports(as % of merchandise exports) of Slovak Republic in 2004?
Your answer should be very brief. -7.14. What is the difference between the Imports(as % of merchandise exports) in Oman in 2001 and the Imports(as % of merchandise exports) in Slovak Republic in 2004?
Offer a very short reply. -9.76. What is the difference between the Imports(as % of merchandise exports) in Denmark in 2001 and the Imports(as % of merchandise exports) in Hungary in 2005?
Provide a short and direct response. -5.98. What is the difference between the Imports(as % of merchandise exports) of Denmark in 2001 and the Imports(as % of merchandise exports) of Oman in 2005?
Keep it short and to the point. 0.03. What is the difference between the Imports(as % of merchandise exports) of Denmark in 2001 and the Imports(as % of merchandise exports) of Slovak Republic in 2005?
Make the answer very short. -9.07. What is the difference between the Imports(as % of merchandise exports) of Hungary in 2001 and the Imports(as % of merchandise exports) of Oman in 2005?
Provide a succinct answer. 1.32. What is the difference between the Imports(as % of merchandise exports) of Hungary in 2001 and the Imports(as % of merchandise exports) of Slovak Republic in 2005?
Ensure brevity in your answer.  -7.78. What is the difference between the Imports(as % of merchandise exports) in Oman in 2001 and the Imports(as % of merchandise exports) in Slovak Republic in 2005?
Keep it short and to the point. -10.4. What is the difference between the Imports(as % of merchandise exports) of Denmark in 2002 and the Imports(as % of merchandise exports) of Hungary in 2003?
Your answer should be compact. -1.21. What is the difference between the Imports(as % of merchandise exports) in Denmark in 2002 and the Imports(as % of merchandise exports) in Oman in 2003?
Keep it short and to the point. -36.04. What is the difference between the Imports(as % of merchandise exports) in Denmark in 2002 and the Imports(as % of merchandise exports) in Slovak Republic in 2003?
Provide a short and direct response. -7.85. What is the difference between the Imports(as % of merchandise exports) in Hungary in 2002 and the Imports(as % of merchandise exports) in Oman in 2003?
Make the answer very short. -33.04. What is the difference between the Imports(as % of merchandise exports) of Hungary in 2002 and the Imports(as % of merchandise exports) of Slovak Republic in 2003?
Keep it short and to the point. -4.85. What is the difference between the Imports(as % of merchandise exports) of Oman in 2002 and the Imports(as % of merchandise exports) of Slovak Republic in 2003?
Offer a very short reply. -10.05. What is the difference between the Imports(as % of merchandise exports) in Denmark in 2002 and the Imports(as % of merchandise exports) in Hungary in 2004?
Ensure brevity in your answer.  -2.86. What is the difference between the Imports(as % of merchandise exports) of Denmark in 2002 and the Imports(as % of merchandise exports) of Oman in 2004?
Provide a short and direct response. 2.02. What is the difference between the Imports(as % of merchandise exports) of Denmark in 2002 and the Imports(as % of merchandise exports) of Slovak Republic in 2004?
Make the answer very short. -8.14. What is the difference between the Imports(as % of merchandise exports) of Hungary in 2002 and the Imports(as % of merchandise exports) of Oman in 2004?
Keep it short and to the point. 5.03. What is the difference between the Imports(as % of merchandise exports) in Hungary in 2002 and the Imports(as % of merchandise exports) in Slovak Republic in 2004?
Offer a terse response. -5.14. What is the difference between the Imports(as % of merchandise exports) of Oman in 2002 and the Imports(as % of merchandise exports) of Slovak Republic in 2004?
Make the answer very short. -10.34. What is the difference between the Imports(as % of merchandise exports) in Denmark in 2002 and the Imports(as % of merchandise exports) in Hungary in 2005?
Offer a very short reply. -5.69. What is the difference between the Imports(as % of merchandise exports) of Denmark in 2002 and the Imports(as % of merchandise exports) of Oman in 2005?
Provide a short and direct response. 0.32. What is the difference between the Imports(as % of merchandise exports) in Denmark in 2002 and the Imports(as % of merchandise exports) in Slovak Republic in 2005?
Your answer should be very brief. -8.78. What is the difference between the Imports(as % of merchandise exports) in Hungary in 2002 and the Imports(as % of merchandise exports) in Oman in 2005?
Provide a succinct answer. 3.33. What is the difference between the Imports(as % of merchandise exports) in Hungary in 2002 and the Imports(as % of merchandise exports) in Slovak Republic in 2005?
Make the answer very short. -5.77. What is the difference between the Imports(as % of merchandise exports) of Oman in 2002 and the Imports(as % of merchandise exports) of Slovak Republic in 2005?
Offer a terse response. -10.98. What is the difference between the Imports(as % of merchandise exports) in Denmark in 2003 and the Imports(as % of merchandise exports) in Hungary in 2004?
Give a very brief answer. -2.52. What is the difference between the Imports(as % of merchandise exports) in Denmark in 2003 and the Imports(as % of merchandise exports) in Oman in 2004?
Offer a terse response. 2.36. What is the difference between the Imports(as % of merchandise exports) of Denmark in 2003 and the Imports(as % of merchandise exports) of Slovak Republic in 2004?
Your response must be concise. -7.8. What is the difference between the Imports(as % of merchandise exports) of Hungary in 2003 and the Imports(as % of merchandise exports) of Oman in 2004?
Your answer should be compact. 3.23. What is the difference between the Imports(as % of merchandise exports) of Hungary in 2003 and the Imports(as % of merchandise exports) of Slovak Republic in 2004?
Your answer should be very brief. -6.94. What is the difference between the Imports(as % of merchandise exports) in Oman in 2003 and the Imports(as % of merchandise exports) in Slovak Republic in 2004?
Offer a very short reply. 27.9. What is the difference between the Imports(as % of merchandise exports) in Denmark in 2003 and the Imports(as % of merchandise exports) in Hungary in 2005?
Keep it short and to the point. -5.35. What is the difference between the Imports(as % of merchandise exports) in Denmark in 2003 and the Imports(as % of merchandise exports) in Oman in 2005?
Offer a very short reply. 0.66. What is the difference between the Imports(as % of merchandise exports) of Denmark in 2003 and the Imports(as % of merchandise exports) of Slovak Republic in 2005?
Keep it short and to the point. -8.44. What is the difference between the Imports(as % of merchandise exports) in Hungary in 2003 and the Imports(as % of merchandise exports) in Oman in 2005?
Ensure brevity in your answer.  1.53. What is the difference between the Imports(as % of merchandise exports) of Hungary in 2003 and the Imports(as % of merchandise exports) of Slovak Republic in 2005?
Give a very brief answer. -7.57. What is the difference between the Imports(as % of merchandise exports) of Oman in 2003 and the Imports(as % of merchandise exports) of Slovak Republic in 2005?
Keep it short and to the point. 27.26. What is the difference between the Imports(as % of merchandise exports) in Denmark in 2004 and the Imports(as % of merchandise exports) in Hungary in 2005?
Give a very brief answer. -4.75. What is the difference between the Imports(as % of merchandise exports) in Denmark in 2004 and the Imports(as % of merchandise exports) in Oman in 2005?
Offer a terse response. 1.26. What is the difference between the Imports(as % of merchandise exports) in Denmark in 2004 and the Imports(as % of merchandise exports) in Slovak Republic in 2005?
Provide a succinct answer. -7.84. What is the difference between the Imports(as % of merchandise exports) of Hungary in 2004 and the Imports(as % of merchandise exports) of Oman in 2005?
Make the answer very short. 3.19. What is the difference between the Imports(as % of merchandise exports) of Hungary in 2004 and the Imports(as % of merchandise exports) of Slovak Republic in 2005?
Keep it short and to the point. -5.92. What is the difference between the Imports(as % of merchandise exports) in Oman in 2004 and the Imports(as % of merchandise exports) in Slovak Republic in 2005?
Your response must be concise. -10.8. What is the average Imports(as % of merchandise exports) in Denmark per year?
Provide a succinct answer. 4.67. What is the average Imports(as % of merchandise exports) in Hungary per year?
Make the answer very short. 6.62. What is the average Imports(as % of merchandise exports) of Oman per year?
Provide a succinct answer. 7.02. What is the average Imports(as % of merchandise exports) in Slovak Republic per year?
Your response must be concise. 13.56. In the year 1998, what is the difference between the Imports(as % of merchandise exports) in Denmark and Imports(as % of merchandise exports) in Hungary?
Offer a terse response. -3.46. In the year 1998, what is the difference between the Imports(as % of merchandise exports) in Denmark and Imports(as % of merchandise exports) in Oman?
Your answer should be compact. 1.89. In the year 1998, what is the difference between the Imports(as % of merchandise exports) in Denmark and Imports(as % of merchandise exports) in Slovak Republic?
Offer a very short reply. -8.09. In the year 1998, what is the difference between the Imports(as % of merchandise exports) of Hungary and Imports(as % of merchandise exports) of Oman?
Make the answer very short. 5.35. In the year 1998, what is the difference between the Imports(as % of merchandise exports) in Hungary and Imports(as % of merchandise exports) in Slovak Republic?
Your response must be concise. -4.63. In the year 1998, what is the difference between the Imports(as % of merchandise exports) of Oman and Imports(as % of merchandise exports) of Slovak Republic?
Your answer should be compact. -9.98. In the year 1999, what is the difference between the Imports(as % of merchandise exports) of Denmark and Imports(as % of merchandise exports) of Hungary?
Offer a very short reply. -2.74. In the year 1999, what is the difference between the Imports(as % of merchandise exports) of Denmark and Imports(as % of merchandise exports) of Oman?
Your answer should be compact. 1.73. In the year 1999, what is the difference between the Imports(as % of merchandise exports) in Denmark and Imports(as % of merchandise exports) in Slovak Republic?
Provide a succinct answer. -9.89. In the year 1999, what is the difference between the Imports(as % of merchandise exports) in Hungary and Imports(as % of merchandise exports) in Oman?
Your answer should be compact. 4.46. In the year 1999, what is the difference between the Imports(as % of merchandise exports) in Hungary and Imports(as % of merchandise exports) in Slovak Republic?
Keep it short and to the point. -7.15. In the year 1999, what is the difference between the Imports(as % of merchandise exports) of Oman and Imports(as % of merchandise exports) of Slovak Republic?
Provide a short and direct response. -11.61. In the year 2000, what is the difference between the Imports(as % of merchandise exports) in Denmark and Imports(as % of merchandise exports) in Hungary?
Keep it short and to the point. 0.95. In the year 2000, what is the difference between the Imports(as % of merchandise exports) of Denmark and Imports(as % of merchandise exports) of Oman?
Give a very brief answer. 4.05. In the year 2000, what is the difference between the Imports(as % of merchandise exports) in Denmark and Imports(as % of merchandise exports) in Slovak Republic?
Give a very brief answer. -11.85. In the year 2000, what is the difference between the Imports(as % of merchandise exports) in Hungary and Imports(as % of merchandise exports) in Oman?
Provide a succinct answer. 3.1. In the year 2000, what is the difference between the Imports(as % of merchandise exports) in Hungary and Imports(as % of merchandise exports) in Slovak Republic?
Keep it short and to the point. -12.81. In the year 2000, what is the difference between the Imports(as % of merchandise exports) of Oman and Imports(as % of merchandise exports) of Slovak Republic?
Offer a terse response. -15.91. In the year 2001, what is the difference between the Imports(as % of merchandise exports) in Denmark and Imports(as % of merchandise exports) in Hungary?
Offer a very short reply. -1.29. In the year 2001, what is the difference between the Imports(as % of merchandise exports) of Denmark and Imports(as % of merchandise exports) of Oman?
Offer a terse response. 1.33. In the year 2001, what is the difference between the Imports(as % of merchandise exports) of Denmark and Imports(as % of merchandise exports) of Slovak Republic?
Your answer should be very brief. -11.15. In the year 2001, what is the difference between the Imports(as % of merchandise exports) in Hungary and Imports(as % of merchandise exports) in Oman?
Provide a succinct answer. 2.62. In the year 2001, what is the difference between the Imports(as % of merchandise exports) of Hungary and Imports(as % of merchandise exports) of Slovak Republic?
Your answer should be very brief. -9.85. In the year 2001, what is the difference between the Imports(as % of merchandise exports) in Oman and Imports(as % of merchandise exports) in Slovak Republic?
Make the answer very short. -12.48. In the year 2002, what is the difference between the Imports(as % of merchandise exports) of Denmark and Imports(as % of merchandise exports) of Hungary?
Your answer should be compact. -3.01. In the year 2002, what is the difference between the Imports(as % of merchandise exports) in Denmark and Imports(as % of merchandise exports) in Oman?
Give a very brief answer. 2.2. In the year 2002, what is the difference between the Imports(as % of merchandise exports) in Denmark and Imports(as % of merchandise exports) in Slovak Republic?
Your response must be concise. -9.12. In the year 2002, what is the difference between the Imports(as % of merchandise exports) in Hungary and Imports(as % of merchandise exports) in Oman?
Your answer should be very brief. 5.2. In the year 2002, what is the difference between the Imports(as % of merchandise exports) of Hungary and Imports(as % of merchandise exports) of Slovak Republic?
Your response must be concise. -6.12. In the year 2002, what is the difference between the Imports(as % of merchandise exports) in Oman and Imports(as % of merchandise exports) in Slovak Republic?
Offer a very short reply. -11.32. In the year 2003, what is the difference between the Imports(as % of merchandise exports) of Denmark and Imports(as % of merchandise exports) of Hungary?
Provide a succinct answer. -0.87. In the year 2003, what is the difference between the Imports(as % of merchandise exports) of Denmark and Imports(as % of merchandise exports) of Oman?
Offer a very short reply. -35.7. In the year 2003, what is the difference between the Imports(as % of merchandise exports) in Denmark and Imports(as % of merchandise exports) in Slovak Republic?
Ensure brevity in your answer.  -7.51. In the year 2003, what is the difference between the Imports(as % of merchandise exports) of Hungary and Imports(as % of merchandise exports) of Oman?
Your answer should be very brief. -34.84. In the year 2003, what is the difference between the Imports(as % of merchandise exports) of Hungary and Imports(as % of merchandise exports) of Slovak Republic?
Your answer should be very brief. -6.65. In the year 2003, what is the difference between the Imports(as % of merchandise exports) in Oman and Imports(as % of merchandise exports) in Slovak Republic?
Ensure brevity in your answer.  28.19. In the year 2004, what is the difference between the Imports(as % of merchandise exports) in Denmark and Imports(as % of merchandise exports) in Hungary?
Your answer should be compact. -1.93. In the year 2004, what is the difference between the Imports(as % of merchandise exports) of Denmark and Imports(as % of merchandise exports) of Oman?
Your answer should be very brief. 2.96. In the year 2004, what is the difference between the Imports(as % of merchandise exports) in Denmark and Imports(as % of merchandise exports) in Slovak Republic?
Your response must be concise. -7.21. In the year 2004, what is the difference between the Imports(as % of merchandise exports) of Hungary and Imports(as % of merchandise exports) of Oman?
Keep it short and to the point. 4.88. In the year 2004, what is the difference between the Imports(as % of merchandise exports) of Hungary and Imports(as % of merchandise exports) of Slovak Republic?
Offer a very short reply. -5.28. In the year 2004, what is the difference between the Imports(as % of merchandise exports) in Oman and Imports(as % of merchandise exports) in Slovak Republic?
Your answer should be compact. -10.16. In the year 2005, what is the difference between the Imports(as % of merchandise exports) in Denmark and Imports(as % of merchandise exports) in Hungary?
Keep it short and to the point. -3.23. In the year 2005, what is the difference between the Imports(as % of merchandise exports) of Denmark and Imports(as % of merchandise exports) of Oman?
Ensure brevity in your answer.  2.78. In the year 2005, what is the difference between the Imports(as % of merchandise exports) of Denmark and Imports(as % of merchandise exports) of Slovak Republic?
Ensure brevity in your answer.  -6.32. In the year 2005, what is the difference between the Imports(as % of merchandise exports) of Hungary and Imports(as % of merchandise exports) of Oman?
Provide a short and direct response. 6.01. In the year 2005, what is the difference between the Imports(as % of merchandise exports) in Hungary and Imports(as % of merchandise exports) in Slovak Republic?
Offer a terse response. -3.09. In the year 2005, what is the difference between the Imports(as % of merchandise exports) of Oman and Imports(as % of merchandise exports) of Slovak Republic?
Ensure brevity in your answer.  -9.1. What is the ratio of the Imports(as % of merchandise exports) in Denmark in 1998 to that in 1999?
Ensure brevity in your answer.  0.92. What is the ratio of the Imports(as % of merchandise exports) in Hungary in 1998 to that in 1999?
Offer a terse response. 1.08. What is the ratio of the Imports(as % of merchandise exports) of Oman in 1998 to that in 1999?
Provide a succinct answer. 0.71. What is the ratio of the Imports(as % of merchandise exports) in Slovak Republic in 1998 to that in 1999?
Your answer should be very brief. 0.84. What is the ratio of the Imports(as % of merchandise exports) in Denmark in 1998 to that in 2000?
Provide a succinct answer. 0.5. What is the ratio of the Imports(as % of merchandise exports) of Hungary in 1998 to that in 2000?
Your response must be concise. 1.33. What is the ratio of the Imports(as % of merchandise exports) in Oman in 1998 to that in 2000?
Make the answer very short. 0.6. What is the ratio of the Imports(as % of merchandise exports) in Slovak Republic in 1998 to that in 2000?
Provide a succinct answer. 0.62. What is the ratio of the Imports(as % of merchandise exports) in Denmark in 1998 to that in 2001?
Your response must be concise. 0.7. What is the ratio of the Imports(as % of merchandise exports) of Hungary in 1998 to that in 2001?
Keep it short and to the point. 1.17. What is the ratio of the Imports(as % of merchandise exports) in Oman in 1998 to that in 2001?
Make the answer very short. 0.35. What is the ratio of the Imports(as % of merchandise exports) in Slovak Republic in 1998 to that in 2001?
Your answer should be compact. 0.72. What is the ratio of the Imports(as % of merchandise exports) of Denmark in 1998 to that in 2002?
Provide a short and direct response. 0.65. What is the ratio of the Imports(as % of merchandise exports) in Hungary in 1998 to that in 2002?
Keep it short and to the point. 0.85. What is the ratio of the Imports(as % of merchandise exports) of Oman in 1998 to that in 2002?
Your response must be concise. 0.45. What is the ratio of the Imports(as % of merchandise exports) in Slovak Republic in 1998 to that in 2002?
Offer a very short reply. 0.81. What is the ratio of the Imports(as % of merchandise exports) of Denmark in 1998 to that in 2003?
Offer a terse response. 0.6. What is the ratio of the Imports(as % of merchandise exports) in Hungary in 1998 to that in 2003?
Make the answer very short. 1.13. What is the ratio of the Imports(as % of merchandise exports) in Oman in 1998 to that in 2003?
Provide a short and direct response. 0.02. What is the ratio of the Imports(as % of merchandise exports) in Slovak Republic in 1998 to that in 2003?
Ensure brevity in your answer.  0.89. What is the ratio of the Imports(as % of merchandise exports) in Denmark in 1998 to that in 2004?
Provide a succinct answer. 0.54. What is the ratio of the Imports(as % of merchandise exports) in Hungary in 1998 to that in 2004?
Offer a terse response. 0.87. What is the ratio of the Imports(as % of merchandise exports) of Oman in 1998 to that in 2004?
Keep it short and to the point. 0.41. What is the ratio of the Imports(as % of merchandise exports) in Slovak Republic in 1998 to that in 2004?
Provide a short and direct response. 0.87. What is the ratio of the Imports(as % of merchandise exports) in Denmark in 1998 to that in 2005?
Provide a succinct answer. 0.42. What is the ratio of the Imports(as % of merchandise exports) in Hungary in 1998 to that in 2005?
Offer a very short reply. 0.63. What is the ratio of the Imports(as % of merchandise exports) in Oman in 1998 to that in 2005?
Keep it short and to the point. 0.24. What is the ratio of the Imports(as % of merchandise exports) of Slovak Republic in 1998 to that in 2005?
Provide a short and direct response. 0.83. What is the ratio of the Imports(as % of merchandise exports) of Denmark in 1999 to that in 2000?
Provide a short and direct response. 0.55. What is the ratio of the Imports(as % of merchandise exports) in Hungary in 1999 to that in 2000?
Your answer should be very brief. 1.23. What is the ratio of the Imports(as % of merchandise exports) of Oman in 1999 to that in 2000?
Your response must be concise. 0.84. What is the ratio of the Imports(as % of merchandise exports) in Slovak Republic in 1999 to that in 2000?
Offer a very short reply. 0.74. What is the ratio of the Imports(as % of merchandise exports) in Denmark in 1999 to that in 2001?
Offer a terse response. 0.75. What is the ratio of the Imports(as % of merchandise exports) of Hungary in 1999 to that in 2001?
Your answer should be compact. 1.08. What is the ratio of the Imports(as % of merchandise exports) of Oman in 1999 to that in 2001?
Ensure brevity in your answer.  0.5. What is the ratio of the Imports(as % of merchandise exports) of Slovak Republic in 1999 to that in 2001?
Make the answer very short. 0.85. What is the ratio of the Imports(as % of merchandise exports) in Denmark in 1999 to that in 2002?
Ensure brevity in your answer.  0.7. What is the ratio of the Imports(as % of merchandise exports) in Hungary in 1999 to that in 2002?
Ensure brevity in your answer.  0.79. What is the ratio of the Imports(as % of merchandise exports) of Oman in 1999 to that in 2002?
Provide a short and direct response. 0.62. What is the ratio of the Imports(as % of merchandise exports) of Slovak Republic in 1999 to that in 2002?
Your response must be concise. 0.96. What is the ratio of the Imports(as % of merchandise exports) in Denmark in 1999 to that in 2003?
Your answer should be very brief. 0.65. What is the ratio of the Imports(as % of merchandise exports) in Hungary in 1999 to that in 2003?
Provide a short and direct response. 1.04. What is the ratio of the Imports(as % of merchandise exports) of Oman in 1999 to that in 2003?
Offer a very short reply. 0.03. What is the ratio of the Imports(as % of merchandise exports) of Slovak Republic in 1999 to that in 2003?
Provide a short and direct response. 1.06. What is the ratio of the Imports(as % of merchandise exports) in Denmark in 1999 to that in 2004?
Keep it short and to the point. 0.58. What is the ratio of the Imports(as % of merchandise exports) of Hungary in 1999 to that in 2004?
Give a very brief answer. 0.8. What is the ratio of the Imports(as % of merchandise exports) in Oman in 1999 to that in 2004?
Keep it short and to the point. 0.58. What is the ratio of the Imports(as % of merchandise exports) of Slovak Republic in 1999 to that in 2004?
Your response must be concise. 1.03. What is the ratio of the Imports(as % of merchandise exports) in Denmark in 1999 to that in 2005?
Keep it short and to the point. 0.45. What is the ratio of the Imports(as % of merchandise exports) of Hungary in 1999 to that in 2005?
Make the answer very short. 0.58. What is the ratio of the Imports(as % of merchandise exports) of Oman in 1999 to that in 2005?
Offer a very short reply. 0.34. What is the ratio of the Imports(as % of merchandise exports) in Slovak Republic in 1999 to that in 2005?
Make the answer very short. 0.98. What is the ratio of the Imports(as % of merchandise exports) of Denmark in 2000 to that in 2001?
Provide a short and direct response. 1.38. What is the ratio of the Imports(as % of merchandise exports) of Hungary in 2000 to that in 2001?
Make the answer very short. 0.88. What is the ratio of the Imports(as % of merchandise exports) of Oman in 2000 to that in 2001?
Give a very brief answer. 0.59. What is the ratio of the Imports(as % of merchandise exports) in Slovak Republic in 2000 to that in 2001?
Give a very brief answer. 1.15. What is the ratio of the Imports(as % of merchandise exports) in Denmark in 2000 to that in 2002?
Keep it short and to the point. 1.29. What is the ratio of the Imports(as % of merchandise exports) in Hungary in 2000 to that in 2002?
Provide a succinct answer. 0.64. What is the ratio of the Imports(as % of merchandise exports) of Oman in 2000 to that in 2002?
Offer a terse response. 0.75. What is the ratio of the Imports(as % of merchandise exports) in Slovak Republic in 2000 to that in 2002?
Your answer should be compact. 1.3. What is the ratio of the Imports(as % of merchandise exports) of Denmark in 2000 to that in 2003?
Your answer should be compact. 1.2. What is the ratio of the Imports(as % of merchandise exports) in Hungary in 2000 to that in 2003?
Provide a succinct answer. 0.85. What is the ratio of the Imports(as % of merchandise exports) in Oman in 2000 to that in 2003?
Ensure brevity in your answer.  0.04. What is the ratio of the Imports(as % of merchandise exports) in Slovak Republic in 2000 to that in 2003?
Keep it short and to the point. 1.43. What is the ratio of the Imports(as % of merchandise exports) of Denmark in 2000 to that in 2004?
Provide a short and direct response. 1.07. What is the ratio of the Imports(as % of merchandise exports) in Hungary in 2000 to that in 2004?
Provide a short and direct response. 0.65. What is the ratio of the Imports(as % of merchandise exports) in Oman in 2000 to that in 2004?
Give a very brief answer. 0.69. What is the ratio of the Imports(as % of merchandise exports) of Slovak Republic in 2000 to that in 2004?
Ensure brevity in your answer.  1.4. What is the ratio of the Imports(as % of merchandise exports) of Denmark in 2000 to that in 2005?
Keep it short and to the point. 0.83. What is the ratio of the Imports(as % of merchandise exports) in Hungary in 2000 to that in 2005?
Give a very brief answer. 0.47. What is the ratio of the Imports(as % of merchandise exports) in Oman in 2000 to that in 2005?
Make the answer very short. 0.41. What is the ratio of the Imports(as % of merchandise exports) in Slovak Republic in 2000 to that in 2005?
Offer a very short reply. 1.33. What is the ratio of the Imports(as % of merchandise exports) of Denmark in 2001 to that in 2002?
Your answer should be compact. 0.93. What is the ratio of the Imports(as % of merchandise exports) of Hungary in 2001 to that in 2002?
Provide a succinct answer. 0.73. What is the ratio of the Imports(as % of merchandise exports) in Oman in 2001 to that in 2002?
Your answer should be very brief. 1.26. What is the ratio of the Imports(as % of merchandise exports) of Slovak Republic in 2001 to that in 2002?
Keep it short and to the point. 1.13. What is the ratio of the Imports(as % of merchandise exports) of Denmark in 2001 to that in 2003?
Keep it short and to the point. 0.87. What is the ratio of the Imports(as % of merchandise exports) of Hungary in 2001 to that in 2003?
Ensure brevity in your answer.  0.96. What is the ratio of the Imports(as % of merchandise exports) in Oman in 2001 to that in 2003?
Offer a very short reply. 0.07. What is the ratio of the Imports(as % of merchandise exports) of Slovak Republic in 2001 to that in 2003?
Provide a short and direct response. 1.24. What is the ratio of the Imports(as % of merchandise exports) of Denmark in 2001 to that in 2004?
Provide a succinct answer. 0.77. What is the ratio of the Imports(as % of merchandise exports) in Hungary in 2001 to that in 2004?
Your answer should be compact. 0.74. What is the ratio of the Imports(as % of merchandise exports) of Oman in 2001 to that in 2004?
Your answer should be compact. 1.17. What is the ratio of the Imports(as % of merchandise exports) of Slovak Republic in 2001 to that in 2004?
Keep it short and to the point. 1.22. What is the ratio of the Imports(as % of merchandise exports) in Denmark in 2001 to that in 2005?
Give a very brief answer. 0.6. What is the ratio of the Imports(as % of merchandise exports) in Hungary in 2001 to that in 2005?
Keep it short and to the point. 0.54. What is the ratio of the Imports(as % of merchandise exports) of Oman in 2001 to that in 2005?
Ensure brevity in your answer.  0.68. What is the ratio of the Imports(as % of merchandise exports) in Slovak Republic in 2001 to that in 2005?
Offer a very short reply. 1.16. What is the ratio of the Imports(as % of merchandise exports) in Denmark in 2002 to that in 2003?
Offer a terse response. 0.93. What is the ratio of the Imports(as % of merchandise exports) in Hungary in 2002 to that in 2003?
Offer a very short reply. 1.32. What is the ratio of the Imports(as % of merchandise exports) of Oman in 2002 to that in 2003?
Ensure brevity in your answer.  0.06. What is the ratio of the Imports(as % of merchandise exports) in Slovak Republic in 2002 to that in 2003?
Provide a succinct answer. 1.1. What is the ratio of the Imports(as % of merchandise exports) in Denmark in 2002 to that in 2004?
Your response must be concise. 0.83. What is the ratio of the Imports(as % of merchandise exports) in Hungary in 2002 to that in 2004?
Make the answer very short. 1.02. What is the ratio of the Imports(as % of merchandise exports) of Oman in 2002 to that in 2004?
Give a very brief answer. 0.93. What is the ratio of the Imports(as % of merchandise exports) in Slovak Republic in 2002 to that in 2004?
Your answer should be very brief. 1.08. What is the ratio of the Imports(as % of merchandise exports) of Denmark in 2002 to that in 2005?
Your response must be concise. 0.64. What is the ratio of the Imports(as % of merchandise exports) in Hungary in 2002 to that in 2005?
Offer a terse response. 0.73. What is the ratio of the Imports(as % of merchandise exports) in Oman in 2002 to that in 2005?
Your answer should be compact. 0.54. What is the ratio of the Imports(as % of merchandise exports) of Slovak Republic in 2002 to that in 2005?
Offer a very short reply. 1.03. What is the ratio of the Imports(as % of merchandise exports) of Denmark in 2003 to that in 2004?
Your response must be concise. 0.89. What is the ratio of the Imports(as % of merchandise exports) of Hungary in 2003 to that in 2004?
Make the answer very short. 0.77. What is the ratio of the Imports(as % of merchandise exports) in Oman in 2003 to that in 2004?
Offer a very short reply. 16.76. What is the ratio of the Imports(as % of merchandise exports) of Slovak Republic in 2003 to that in 2004?
Your response must be concise. 0.98. What is the ratio of the Imports(as % of merchandise exports) in Denmark in 2003 to that in 2005?
Your answer should be very brief. 0.69. What is the ratio of the Imports(as % of merchandise exports) of Hungary in 2003 to that in 2005?
Ensure brevity in your answer.  0.56. What is the ratio of the Imports(as % of merchandise exports) of Oman in 2003 to that in 2005?
Your response must be concise. 9.84. What is the ratio of the Imports(as % of merchandise exports) in Slovak Republic in 2003 to that in 2005?
Keep it short and to the point. 0.93. What is the ratio of the Imports(as % of merchandise exports) of Denmark in 2004 to that in 2005?
Your response must be concise. 0.78. What is the ratio of the Imports(as % of merchandise exports) of Hungary in 2004 to that in 2005?
Ensure brevity in your answer.  0.72. What is the ratio of the Imports(as % of merchandise exports) in Oman in 2004 to that in 2005?
Give a very brief answer. 0.59. What is the ratio of the Imports(as % of merchandise exports) in Slovak Republic in 2004 to that in 2005?
Offer a terse response. 0.95. What is the difference between the highest and the second highest Imports(as % of merchandise exports) in Denmark?
Provide a succinct answer. 1.17. What is the difference between the highest and the second highest Imports(as % of merchandise exports) of Hungary?
Provide a short and direct response. 2.68. What is the difference between the highest and the second highest Imports(as % of merchandise exports) in Oman?
Your answer should be very brief. 36.37. What is the difference between the highest and the second highest Imports(as % of merchandise exports) of Slovak Republic?
Offer a terse response. 2.29. What is the difference between the highest and the lowest Imports(as % of merchandise exports) in Denmark?
Your response must be concise. 4.01. What is the difference between the highest and the lowest Imports(as % of merchandise exports) in Hungary?
Your response must be concise. 5.36. What is the difference between the highest and the lowest Imports(as % of merchandise exports) in Oman?
Offer a terse response. 39.48. What is the difference between the highest and the lowest Imports(as % of merchandise exports) of Slovak Republic?
Ensure brevity in your answer.  6.6. 